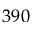<formula> <loc_0><loc_0><loc_500><loc_500>3 9 0</formula> 